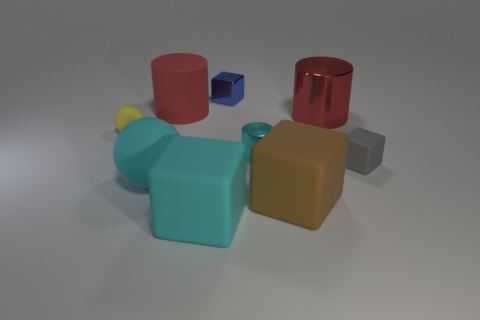Is the large ball the same color as the small shiny cylinder?
Your answer should be compact. Yes. How many big brown objects are the same shape as the small cyan thing?
Your answer should be very brief. 0. What shape is the cyan matte thing on the left side of the big cyan thing that is right of the large matte cylinder?
Keep it short and to the point. Sphere. Does the red cylinder that is on the right side of the blue metal block have the same size as the tiny metal block?
Keep it short and to the point. No. There is a cyan object that is both behind the brown rubber thing and on the left side of the blue metal cube; how big is it?
Ensure brevity in your answer.  Large. What number of brown objects have the same size as the gray rubber thing?
Keep it short and to the point. 0. What number of cyan matte objects are to the left of the big matte thing that is behind the gray matte thing?
Ensure brevity in your answer.  1. Is the color of the metal cylinder right of the small cyan shiny cylinder the same as the matte cylinder?
Your response must be concise. Yes. There is a matte ball that is behind the gray rubber object that is to the right of the large red matte cylinder; are there any big red objects behind it?
Provide a succinct answer. Yes. There is a shiny thing that is both to the right of the tiny blue shiny object and to the left of the large brown matte object; what is its shape?
Your answer should be compact. Cylinder. 